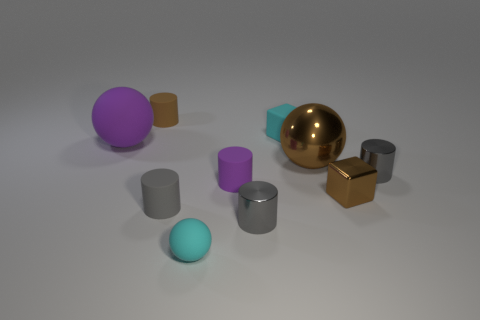What number of other objects are the same color as the metallic sphere?
Keep it short and to the point. 2. The large thing on the left side of the sphere that is in front of the gray cylinder that is to the left of the small cyan matte sphere is what color?
Your response must be concise. Purple. What shape is the purple rubber thing that is the same size as the cyan block?
Ensure brevity in your answer.  Cylinder. Is the number of big gray metallic things greater than the number of brown matte cylinders?
Make the answer very short. No. Are there any big purple things in front of the tiny gray metallic object that is in front of the tiny gray matte object?
Your response must be concise. No. What color is the other large thing that is the same shape as the large purple object?
Make the answer very short. Brown. Is there any other thing that is the same shape as the gray rubber thing?
Your answer should be compact. Yes. The tiny block that is the same material as the purple ball is what color?
Make the answer very short. Cyan. There is a tiny gray metal object that is in front of the small brown cube that is to the right of the tiny cyan rubber ball; are there any big purple matte spheres that are right of it?
Provide a succinct answer. No. Is the number of large metallic balls that are to the left of the purple cylinder less than the number of tiny shiny objects that are in front of the cyan rubber ball?
Give a very brief answer. No. 